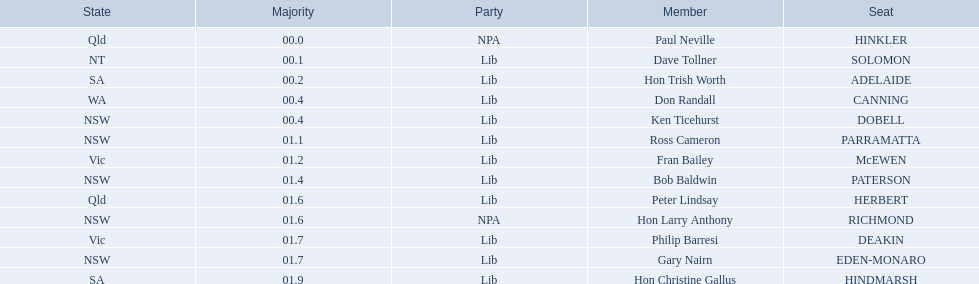Who are all the lib party members? Dave Tollner, Hon Trish Worth, Don Randall, Ken Ticehurst, Ross Cameron, Fran Bailey, Bob Baldwin, Peter Lindsay, Philip Barresi, Gary Nairn, Hon Christine Gallus. What lib party members are in sa? Hon Trish Worth, Hon Christine Gallus. What is the highest difference in majority between members in sa? 01.9. 